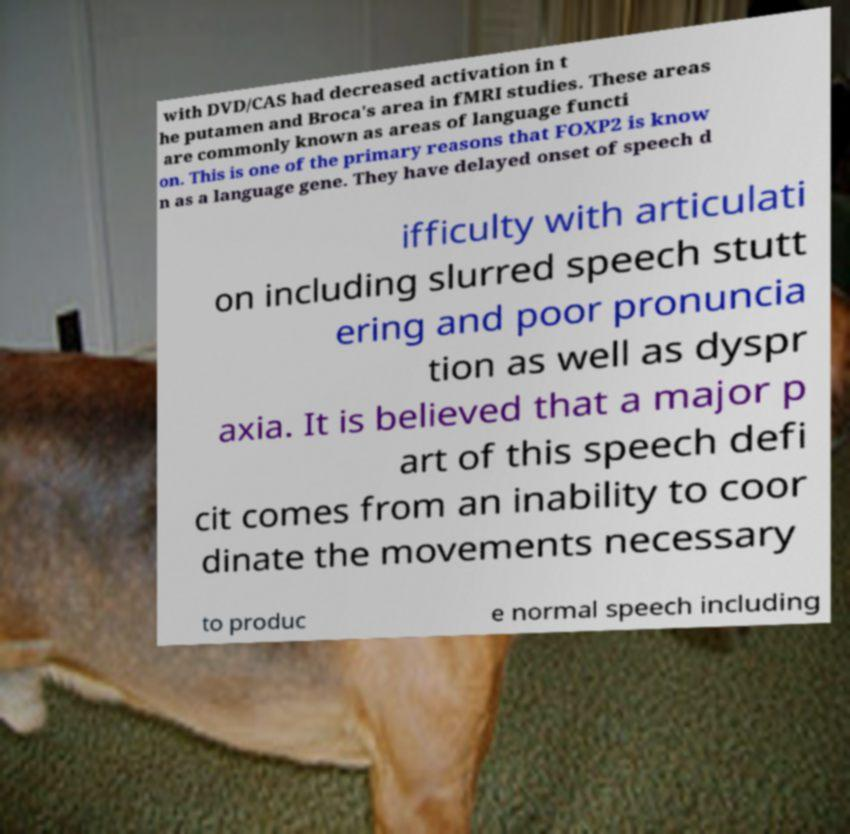Can you accurately transcribe the text from the provided image for me? with DVD/CAS had decreased activation in t he putamen and Broca's area in fMRI studies. These areas are commonly known as areas of language functi on. This is one of the primary reasons that FOXP2 is know n as a language gene. They have delayed onset of speech d ifficulty with articulati on including slurred speech stutt ering and poor pronuncia tion as well as dyspr axia. It is believed that a major p art of this speech defi cit comes from an inability to coor dinate the movements necessary to produc e normal speech including 